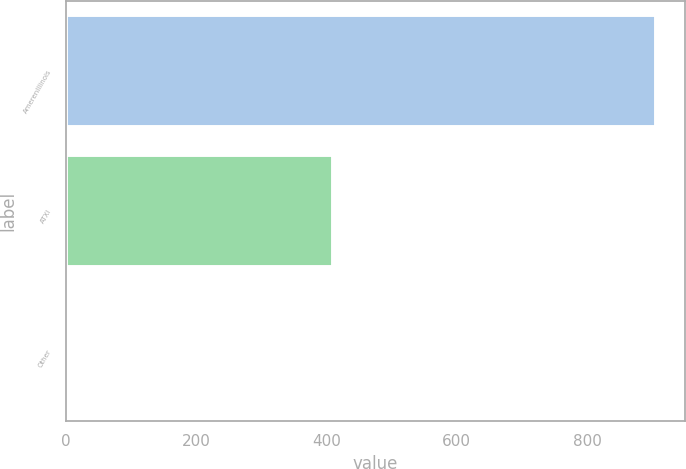<chart> <loc_0><loc_0><loc_500><loc_500><bar_chart><fcel>AmerenIllinois<fcel>ATXI<fcel>Other<nl><fcel>905<fcel>410<fcel>5<nl></chart> 